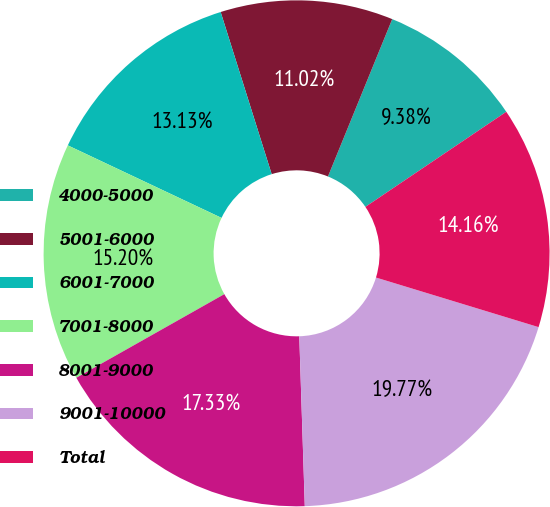Convert chart. <chart><loc_0><loc_0><loc_500><loc_500><pie_chart><fcel>4000-5000<fcel>5001-6000<fcel>6001-7000<fcel>7001-8000<fcel>8001-9000<fcel>9001-10000<fcel>Total<nl><fcel>9.38%<fcel>11.02%<fcel>13.13%<fcel>15.2%<fcel>17.33%<fcel>19.77%<fcel>14.16%<nl></chart> 